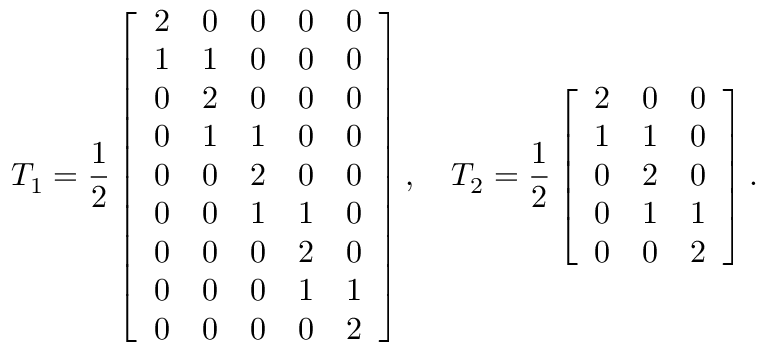Convert formula to latex. <formula><loc_0><loc_0><loc_500><loc_500>T _ { 1 } = \frac { 1 } { 2 } \left [ \begin{array} { l l l l l } { 2 } & { 0 } & { 0 } & { 0 } & { 0 } \\ { 1 } & { 1 } & { 0 } & { 0 } & { 0 } \\ { 0 } & { 2 } & { 0 } & { 0 } & { 0 } \\ { 0 } & { 1 } & { 1 } & { 0 } & { 0 } \\ { 0 } & { 0 } & { 2 } & { 0 } & { 0 } \\ { 0 } & { 0 } & { 1 } & { 1 } & { 0 } \\ { 0 } & { 0 } & { 0 } & { 2 } & { 0 } \\ { 0 } & { 0 } & { 0 } & { 1 } & { 1 } \\ { 0 } & { 0 } & { 0 } & { 0 } & { 2 } \end{array} \right ] , \quad T _ { 2 } = \frac { 1 } { 2 } \left [ \begin{array} { l l l } { 2 } & { 0 } & { 0 } \\ { 1 } & { 1 } & { 0 } \\ { 0 } & { 2 } & { 0 } \\ { 0 } & { 1 } & { 1 } \\ { 0 } & { 0 } & { 2 } \end{array} \right ] .</formula> 